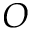Convert formula to latex. <formula><loc_0><loc_0><loc_500><loc_500>O</formula> 